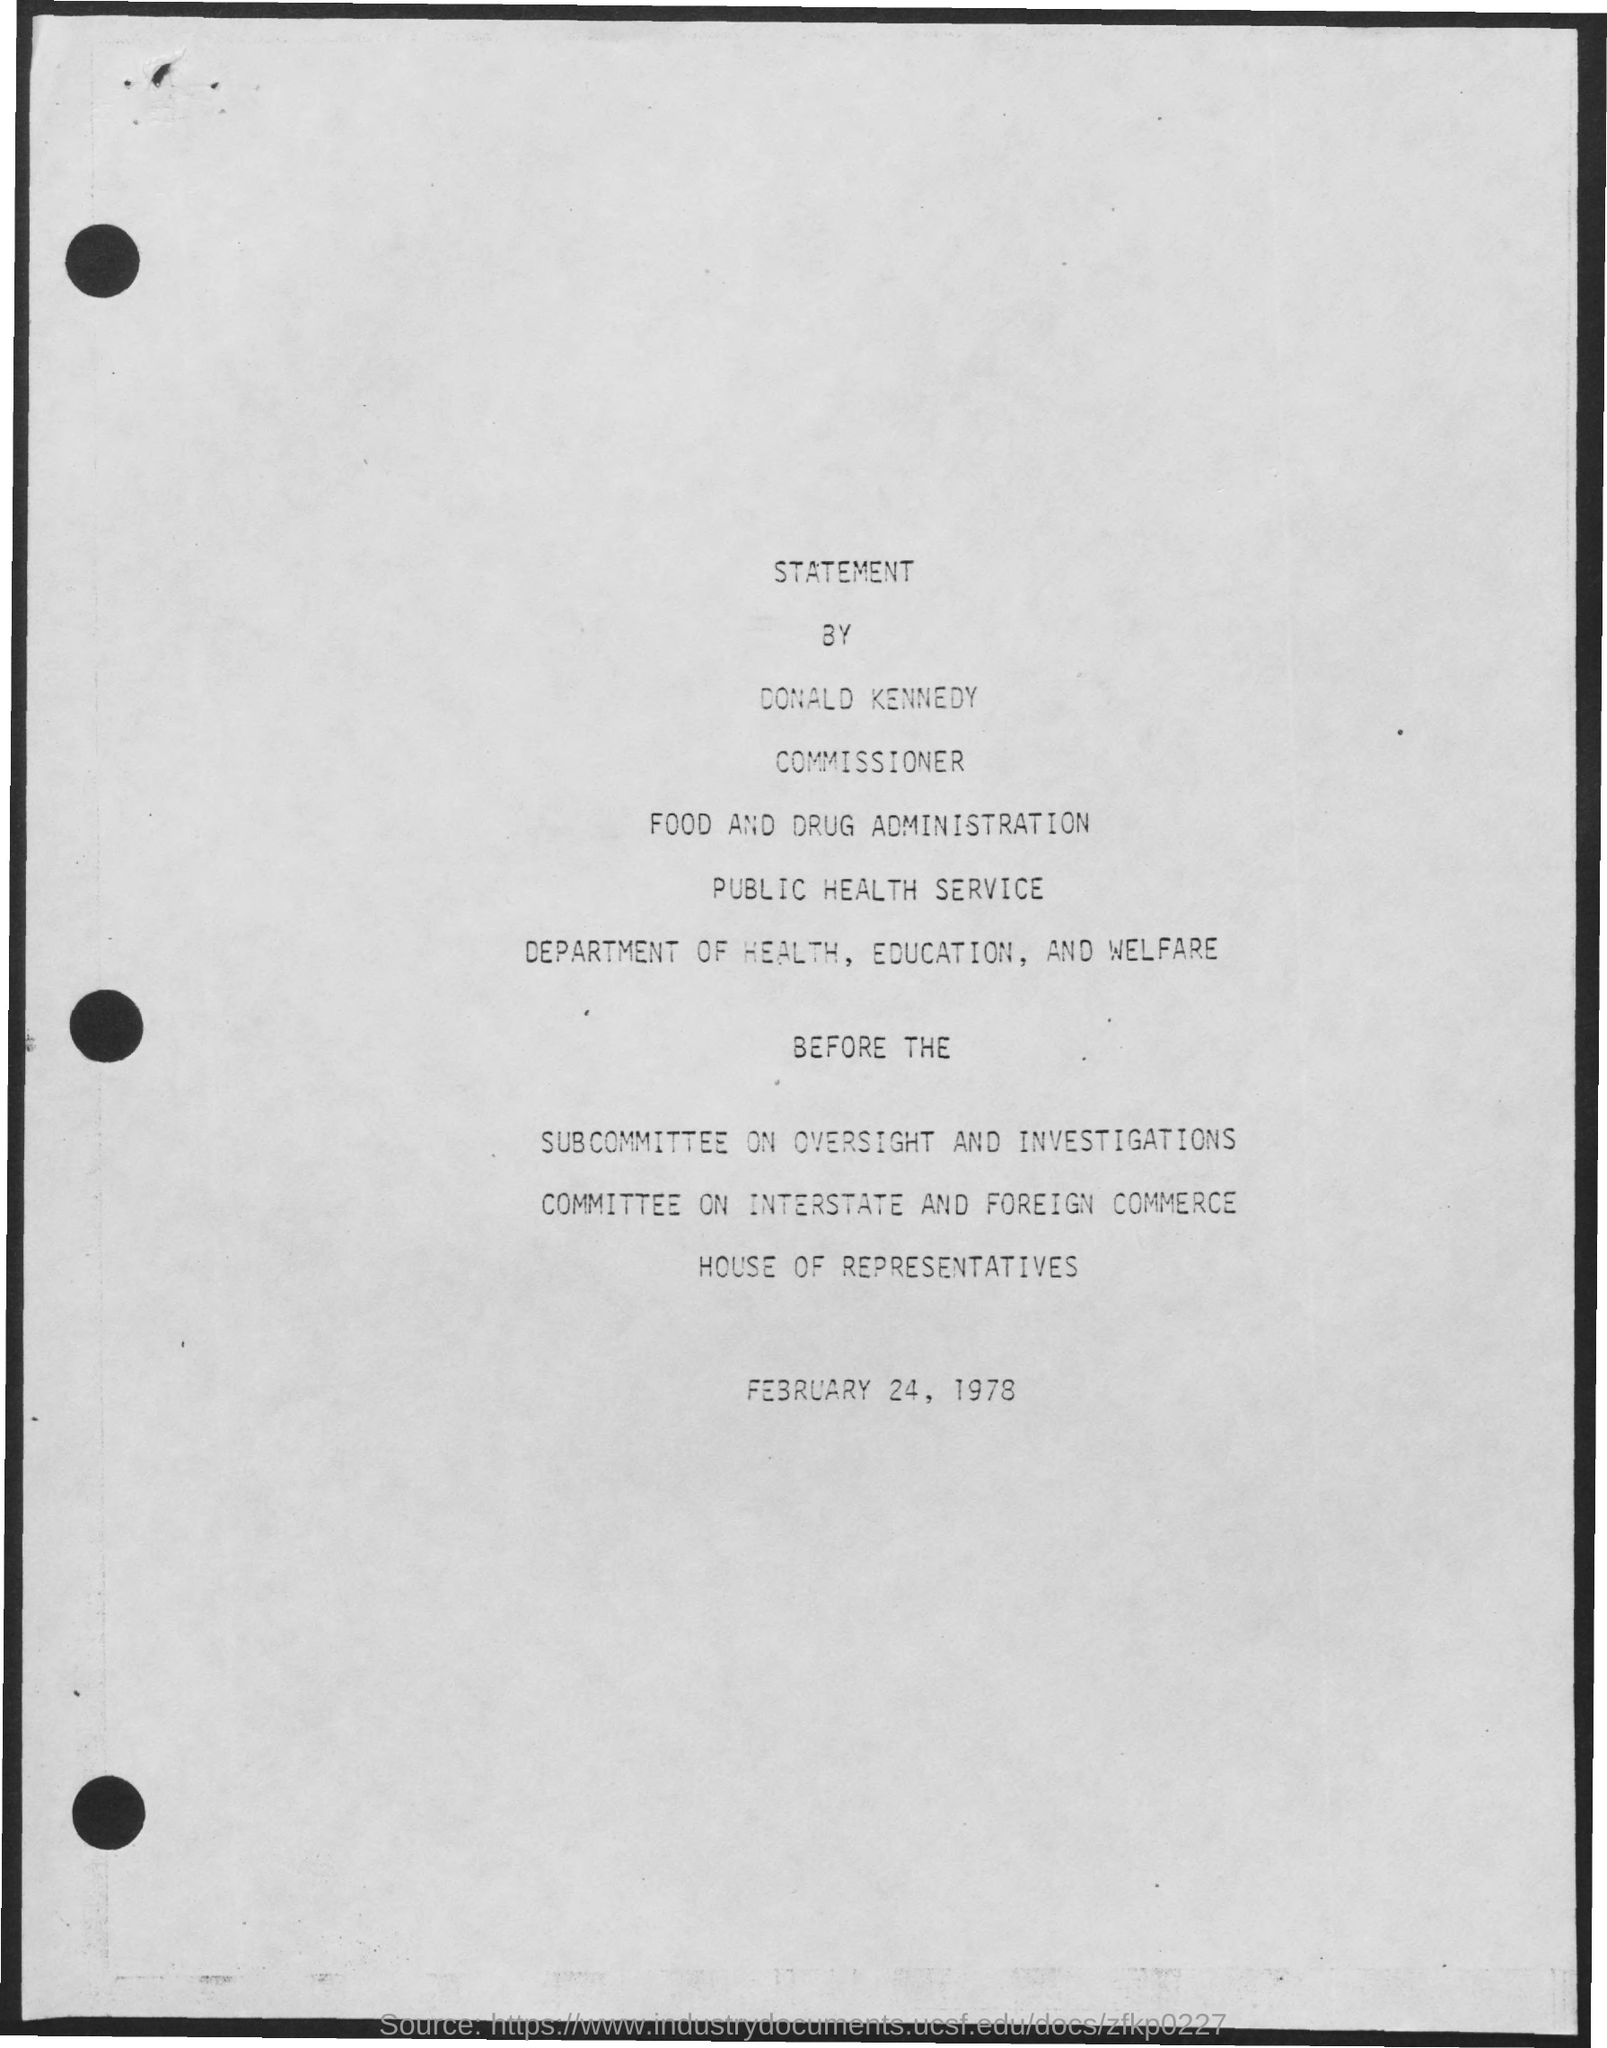Mention a couple of crucial points in this snapshot. The date mentioned in the document is February 24, 1978. 